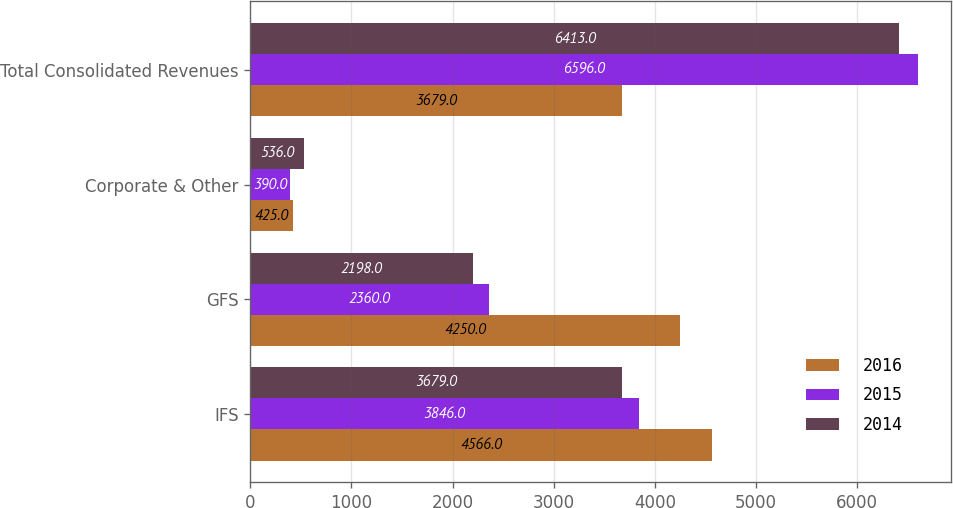Convert chart. <chart><loc_0><loc_0><loc_500><loc_500><stacked_bar_chart><ecel><fcel>IFS<fcel>GFS<fcel>Corporate & Other<fcel>Total Consolidated Revenues<nl><fcel>2016<fcel>4566<fcel>4250<fcel>425<fcel>3679<nl><fcel>2015<fcel>3846<fcel>2360<fcel>390<fcel>6596<nl><fcel>2014<fcel>3679<fcel>2198<fcel>536<fcel>6413<nl></chart> 